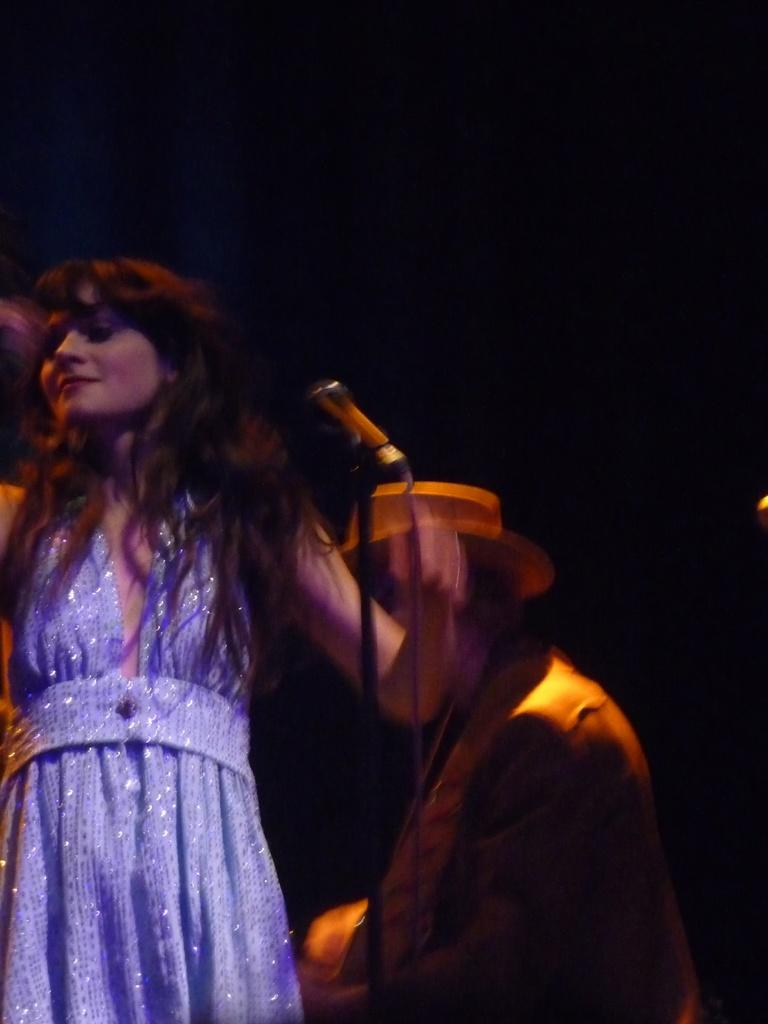Who is the main subject in the image? There is a woman in the image. What is the woman wearing? The woman is wearing a purple dress. What is the woman doing in the image? The woman is standing. What object is in front of the woman? There is a microphone with a stand in front of the woman. Who is behind the woman in the image? There is a man behind the woman. How would you describe the background of the image? The background of the image is dark. What type of jam is being spread on the squirrel in the image? There is no squirrel or jam present in the image. 